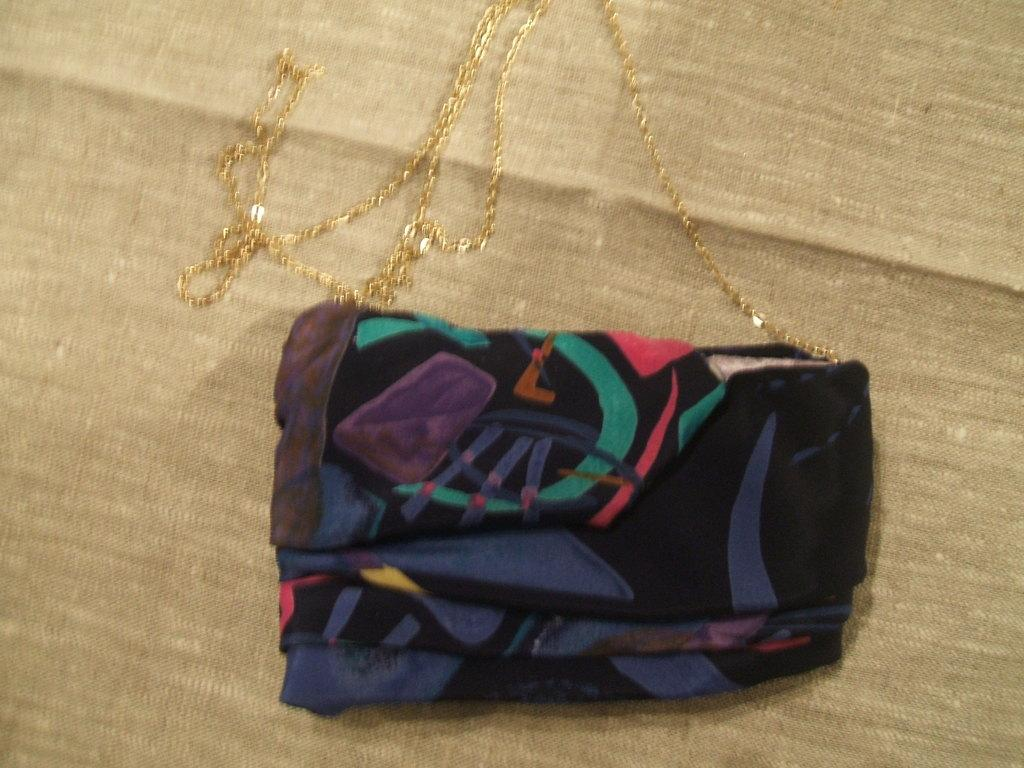What type of material is present in the image? There is a cloth in the image. What other object can be seen in the image? There is a chain in the image. What type of box can be seen in the wilderness in the image? There is no box or wilderness present in the image; it only features a cloth and a chain. 